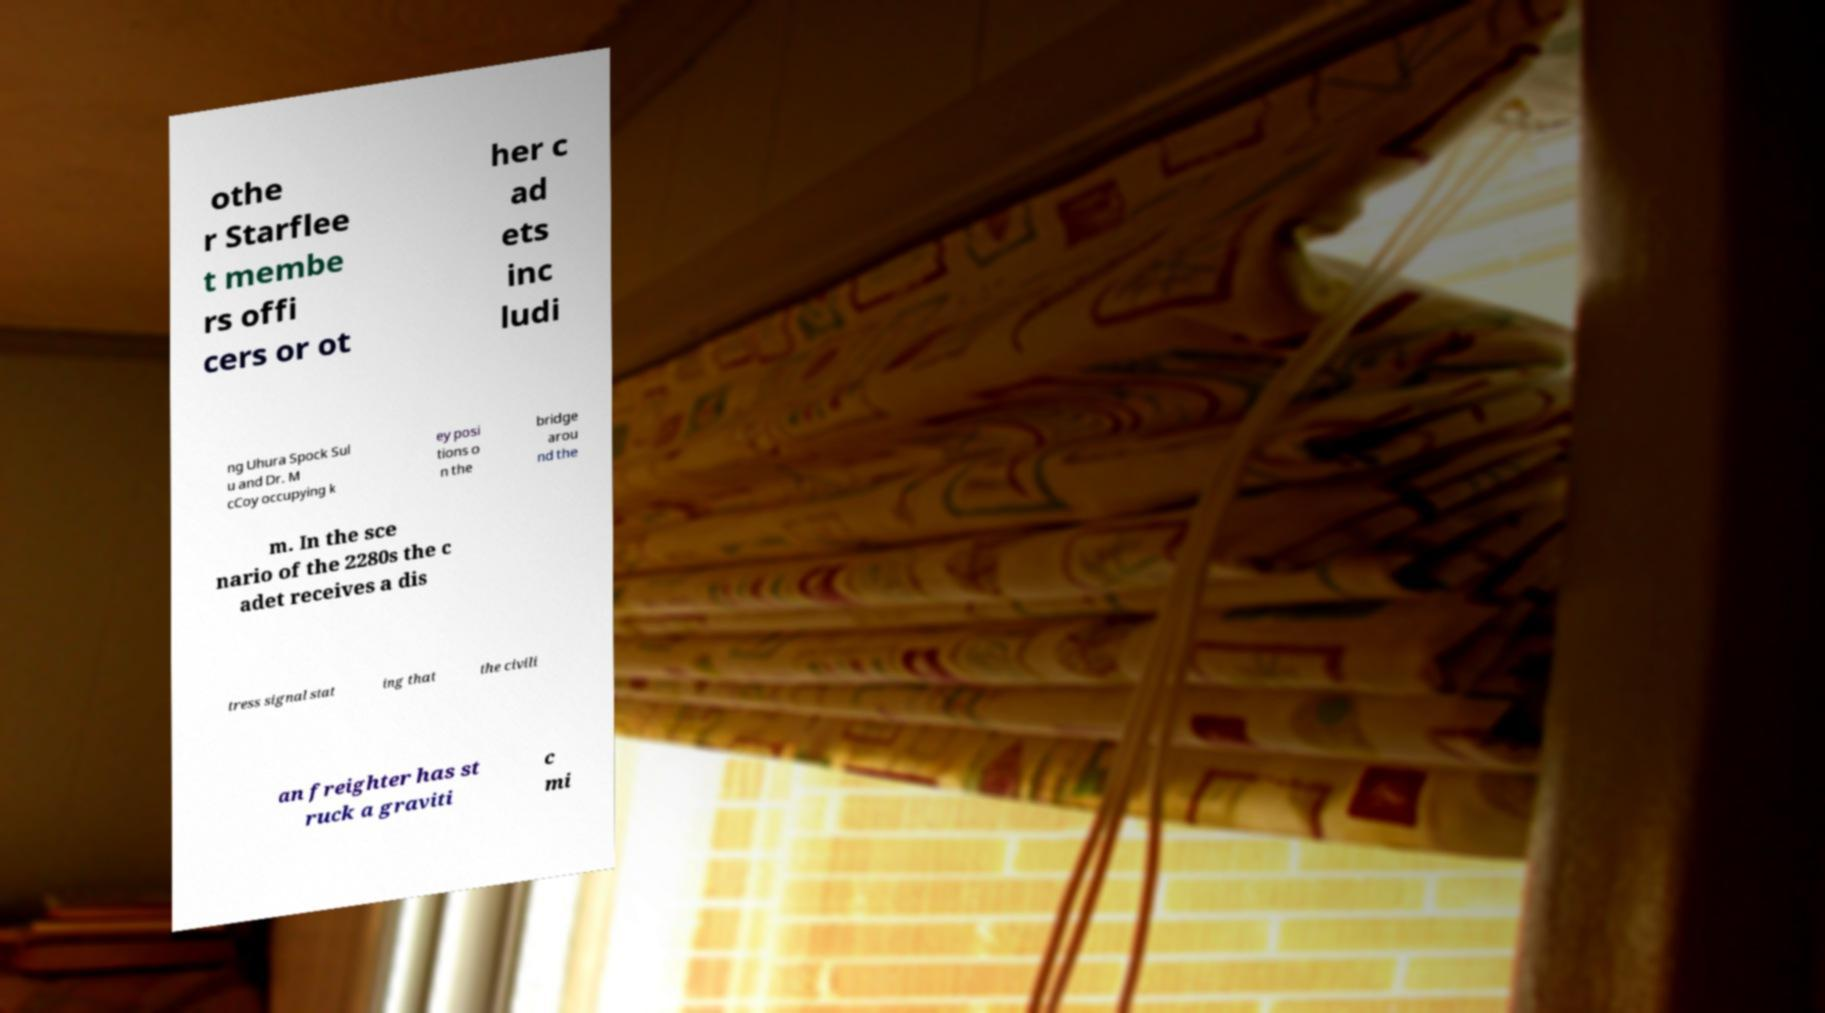For documentation purposes, I need the text within this image transcribed. Could you provide that? othe r Starflee t membe rs offi cers or ot her c ad ets inc ludi ng Uhura Spock Sul u and Dr. M cCoy occupying k ey posi tions o n the bridge arou nd the m. In the sce nario of the 2280s the c adet receives a dis tress signal stat ing that the civili an freighter has st ruck a graviti c mi 